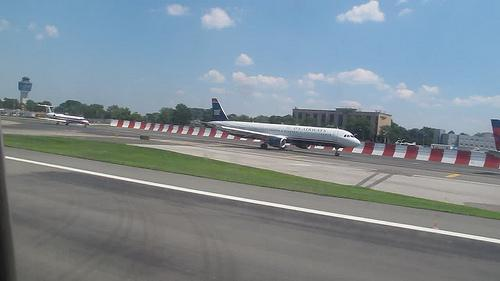Question: what is the color of the wall?
Choices:
A. White and red.
B. Brown.
C. Blue.
D. Green.
Answer with the letter. Answer: A Question: what color is the sky?
Choices:
A. Blue.
B. White.
C. Pink.
D. Blue and white.
Answer with the letter. Answer: D 